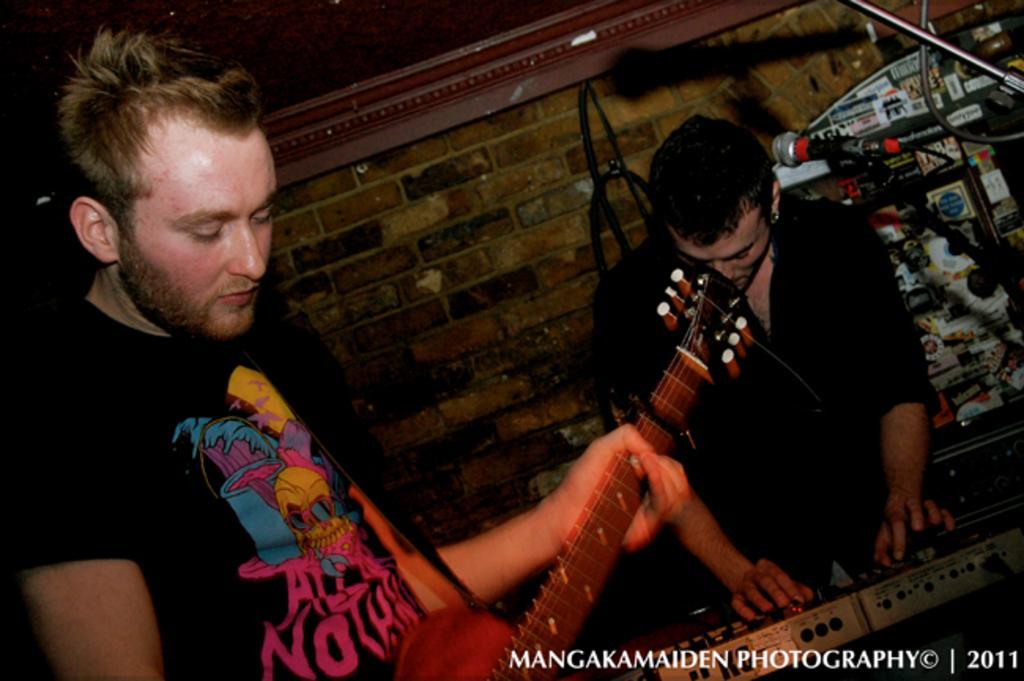How would you summarize this image in a sentence or two? In this picture at right corner one person is standing in black dress and operating a keyboard and at the left corner one person is standing and holding a guitar, behind them there is a wall. 